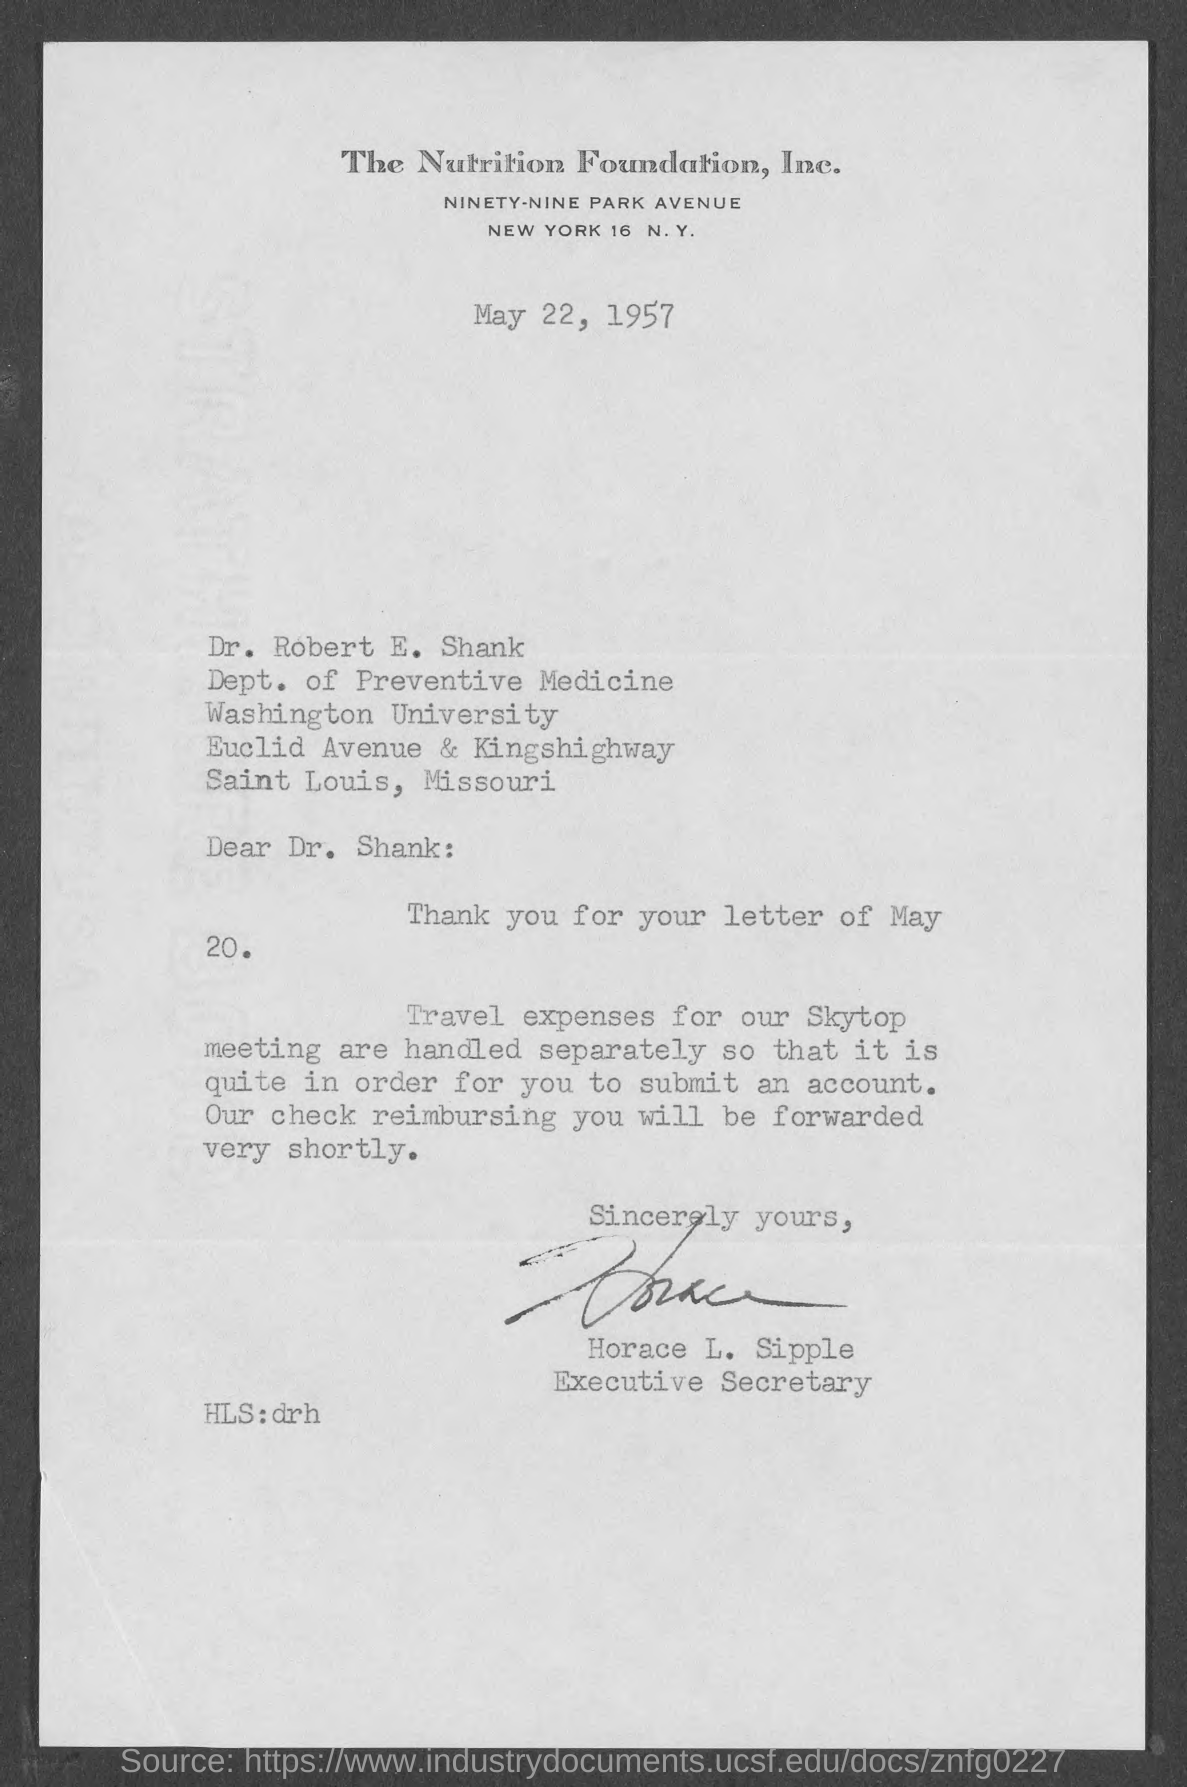Indicate a few pertinent items in this graphic. The document indicates that the date is May 22, 1957. Separate travel expenses will be incurred for skytop meetings. 